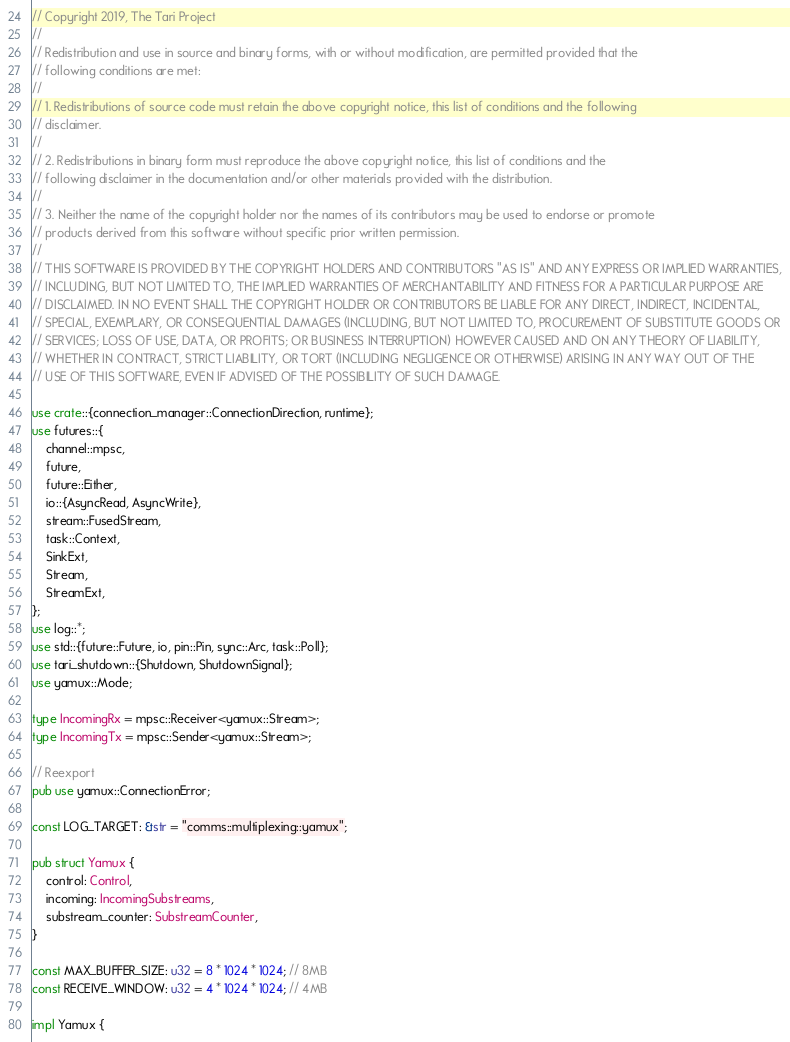Convert code to text. <code><loc_0><loc_0><loc_500><loc_500><_Rust_>// Copyright 2019, The Tari Project
//
// Redistribution and use in source and binary forms, with or without modification, are permitted provided that the
// following conditions are met:
//
// 1. Redistributions of source code must retain the above copyright notice, this list of conditions and the following
// disclaimer.
//
// 2. Redistributions in binary form must reproduce the above copyright notice, this list of conditions and the
// following disclaimer in the documentation and/or other materials provided with the distribution.
//
// 3. Neither the name of the copyright holder nor the names of its contributors may be used to endorse or promote
// products derived from this software without specific prior written permission.
//
// THIS SOFTWARE IS PROVIDED BY THE COPYRIGHT HOLDERS AND CONTRIBUTORS "AS IS" AND ANY EXPRESS OR IMPLIED WARRANTIES,
// INCLUDING, BUT NOT LIMITED TO, THE IMPLIED WARRANTIES OF MERCHANTABILITY AND FITNESS FOR A PARTICULAR PURPOSE ARE
// DISCLAIMED. IN NO EVENT SHALL THE COPYRIGHT HOLDER OR CONTRIBUTORS BE LIABLE FOR ANY DIRECT, INDIRECT, INCIDENTAL,
// SPECIAL, EXEMPLARY, OR CONSEQUENTIAL DAMAGES (INCLUDING, BUT NOT LIMITED TO, PROCUREMENT OF SUBSTITUTE GOODS OR
// SERVICES; LOSS OF USE, DATA, OR PROFITS; OR BUSINESS INTERRUPTION) HOWEVER CAUSED AND ON ANY THEORY OF LIABILITY,
// WHETHER IN CONTRACT, STRICT LIABILITY, OR TORT (INCLUDING NEGLIGENCE OR OTHERWISE) ARISING IN ANY WAY OUT OF THE
// USE OF THIS SOFTWARE, EVEN IF ADVISED OF THE POSSIBILITY OF SUCH DAMAGE.

use crate::{connection_manager::ConnectionDirection, runtime};
use futures::{
    channel::mpsc,
    future,
    future::Either,
    io::{AsyncRead, AsyncWrite},
    stream::FusedStream,
    task::Context,
    SinkExt,
    Stream,
    StreamExt,
};
use log::*;
use std::{future::Future, io, pin::Pin, sync::Arc, task::Poll};
use tari_shutdown::{Shutdown, ShutdownSignal};
use yamux::Mode;

type IncomingRx = mpsc::Receiver<yamux::Stream>;
type IncomingTx = mpsc::Sender<yamux::Stream>;

// Reexport
pub use yamux::ConnectionError;

const LOG_TARGET: &str = "comms::multiplexing::yamux";

pub struct Yamux {
    control: Control,
    incoming: IncomingSubstreams,
    substream_counter: SubstreamCounter,
}

const MAX_BUFFER_SIZE: u32 = 8 * 1024 * 1024; // 8MB
const RECEIVE_WINDOW: u32 = 4 * 1024 * 1024; // 4MB

impl Yamux {</code> 